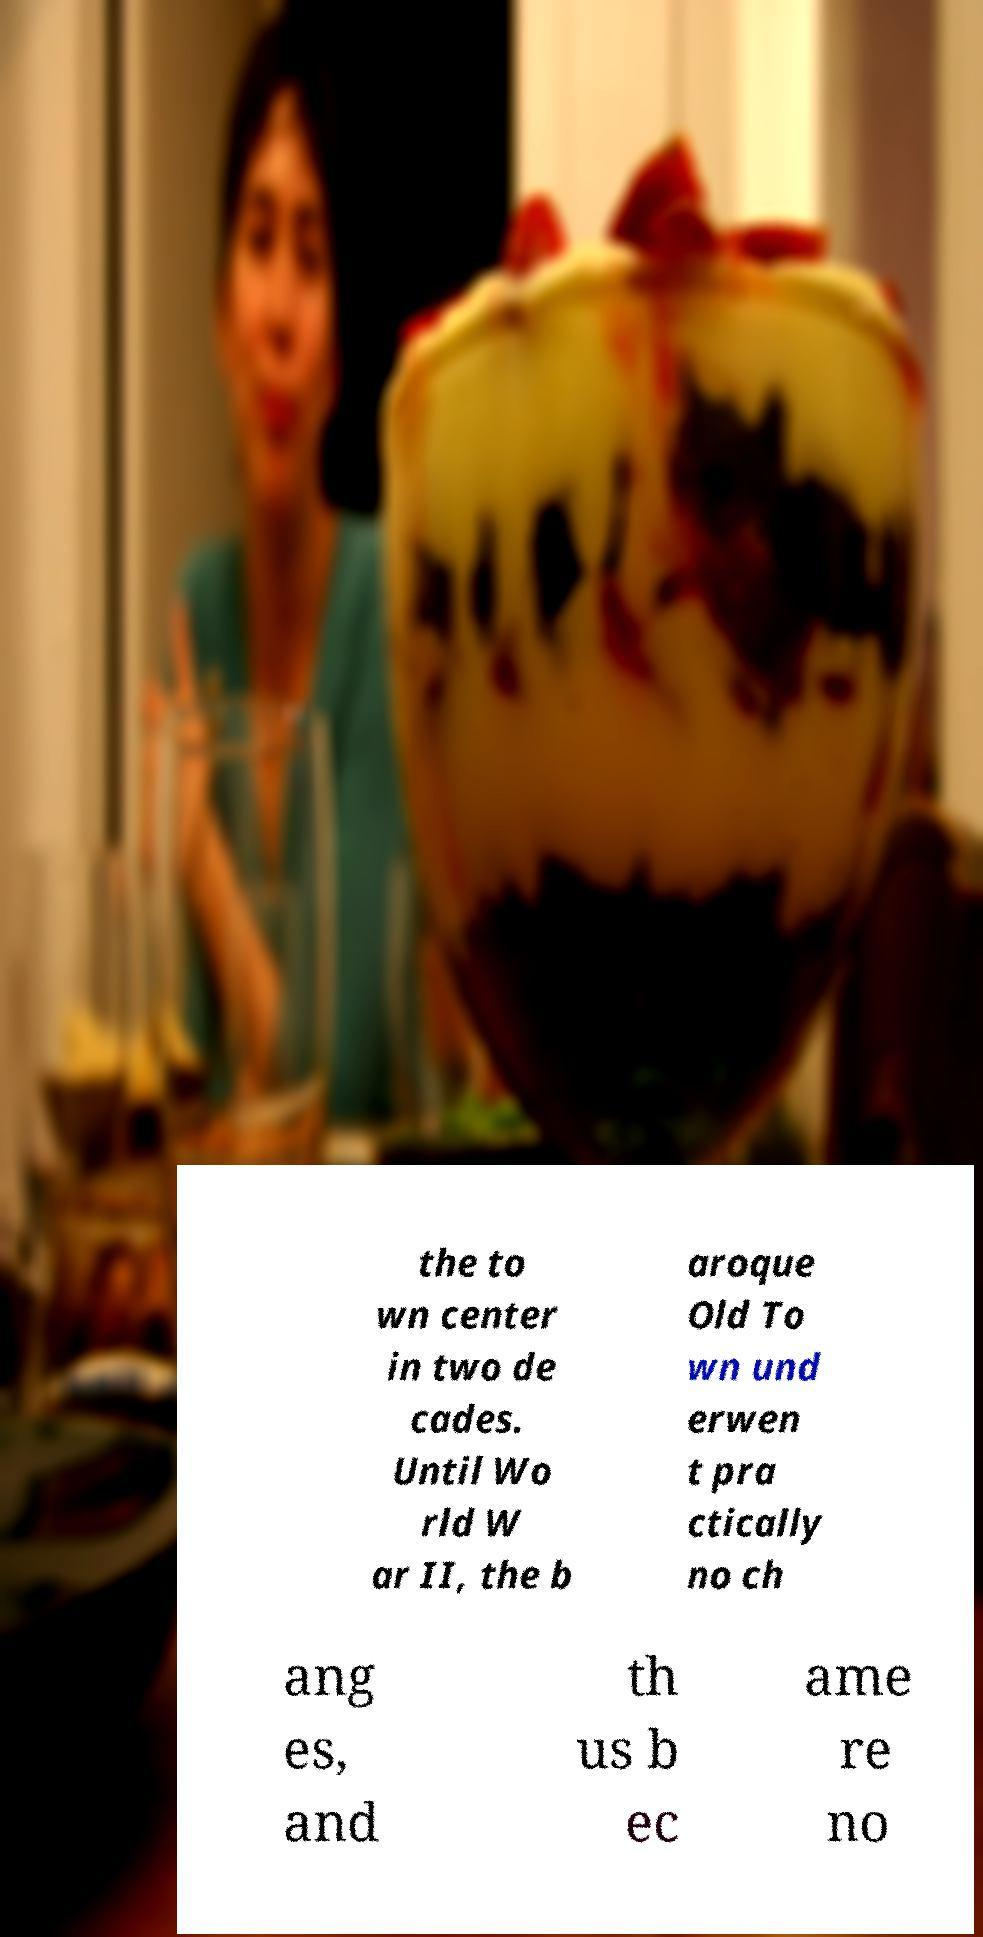Please identify and transcribe the text found in this image. the to wn center in two de cades. Until Wo rld W ar II, the b aroque Old To wn und erwen t pra ctically no ch ang es, and th us b ec ame re no 